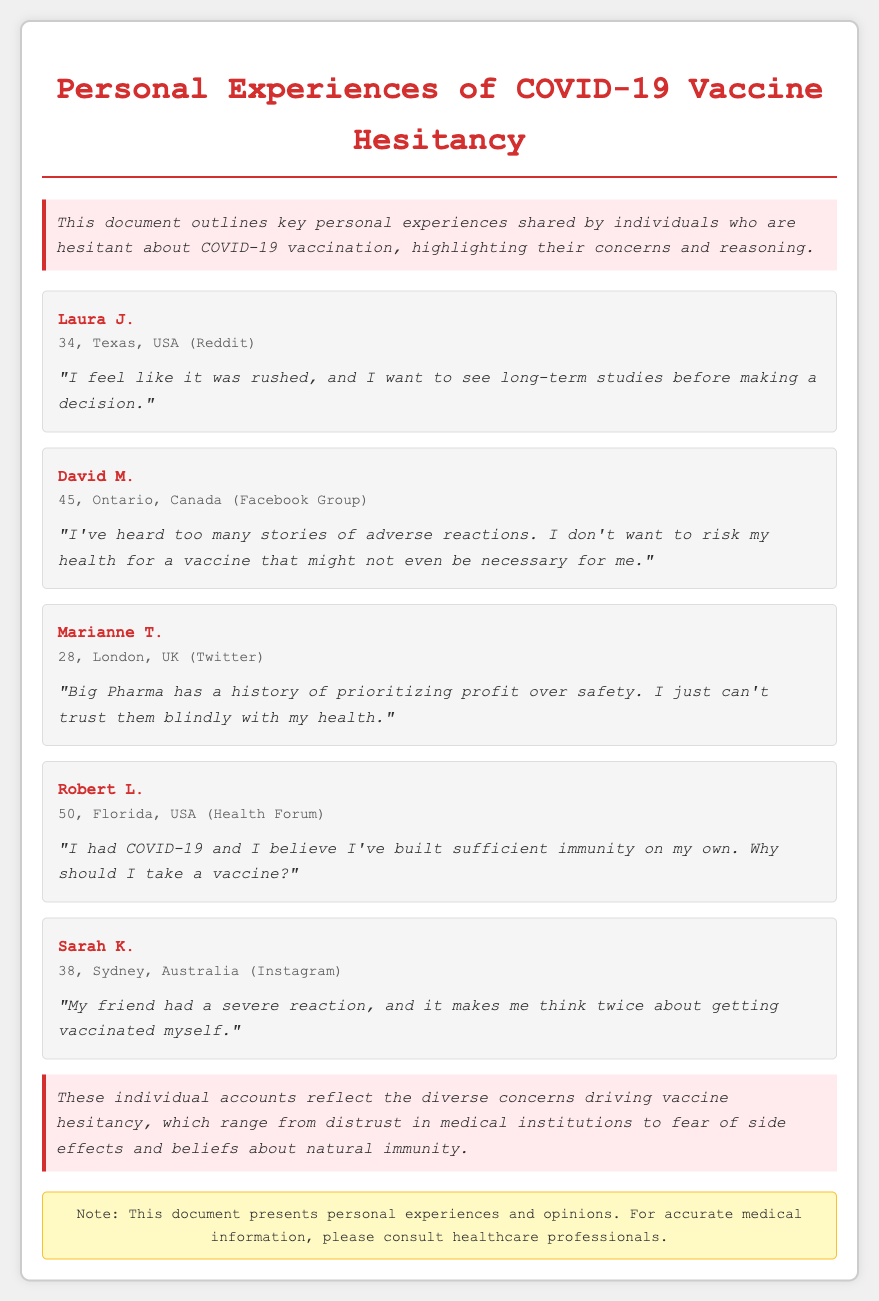What is the name of the first person mentioned? The first person mentioned in the document is Laura J.
Answer: Laura J How old is David M.? David M.'s age is explicitly stated in the document.
Answer: 45 What platform did Marianne T. share her experience on? The document specifies the platform where Marianne T. shared her experience.
Answer: Twitter What is Robert L.'s main reason for not getting vaccinated? Robert L. gives a specific reasoning based on his prior experience with COVID-19.
Answer: Built sufficient immunity How many people shared their experiences in total? The document lists a count of individual accounts provided.
Answer: Five What is a common reason for vaccine hesitancy mentioned in the document? The document outlines several reasons for vaccine hesitancy among individuals.
Answer: Distrust in medical institutions What color is the background of the container in the document? The styling of the document specifies the background color of the container.
Answer: White What does the warning note emphasize? The warning note gives specific advice regarding the document's content.
Answer: Consult healthcare professionals 